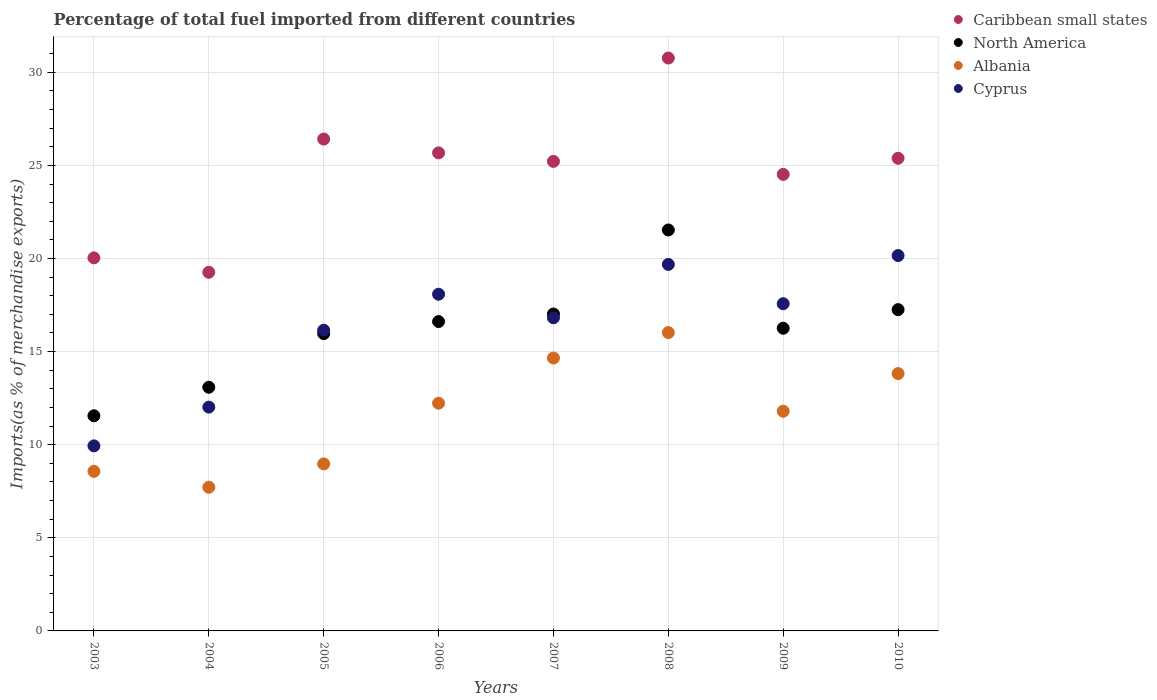Is the number of dotlines equal to the number of legend labels?
Ensure brevity in your answer.  Yes. What is the percentage of imports to different countries in Cyprus in 2005?
Provide a short and direct response. 16.15. Across all years, what is the maximum percentage of imports to different countries in Albania?
Keep it short and to the point. 16.02. Across all years, what is the minimum percentage of imports to different countries in Cyprus?
Offer a very short reply. 9.94. In which year was the percentage of imports to different countries in Cyprus minimum?
Give a very brief answer. 2003. What is the total percentage of imports to different countries in Cyprus in the graph?
Make the answer very short. 130.41. What is the difference between the percentage of imports to different countries in Caribbean small states in 2008 and that in 2009?
Provide a short and direct response. 6.25. What is the difference between the percentage of imports to different countries in Cyprus in 2007 and the percentage of imports to different countries in North America in 2009?
Your response must be concise. 0.56. What is the average percentage of imports to different countries in Albania per year?
Offer a terse response. 11.72. In the year 2003, what is the difference between the percentage of imports to different countries in Cyprus and percentage of imports to different countries in North America?
Provide a succinct answer. -1.62. In how many years, is the percentage of imports to different countries in North America greater than 29 %?
Your answer should be compact. 0. What is the ratio of the percentage of imports to different countries in North America in 2008 to that in 2010?
Your answer should be compact. 1.25. What is the difference between the highest and the second highest percentage of imports to different countries in Albania?
Your answer should be compact. 1.37. What is the difference between the highest and the lowest percentage of imports to different countries in Caribbean small states?
Your answer should be compact. 11.51. Is the sum of the percentage of imports to different countries in Cyprus in 2003 and 2004 greater than the maximum percentage of imports to different countries in North America across all years?
Your answer should be compact. Yes. Does the percentage of imports to different countries in Cyprus monotonically increase over the years?
Provide a succinct answer. No. Is the percentage of imports to different countries in North America strictly greater than the percentage of imports to different countries in Cyprus over the years?
Make the answer very short. No. Does the graph contain any zero values?
Ensure brevity in your answer.  No. Where does the legend appear in the graph?
Offer a terse response. Top right. What is the title of the graph?
Give a very brief answer. Percentage of total fuel imported from different countries. Does "Monaco" appear as one of the legend labels in the graph?
Provide a succinct answer. No. What is the label or title of the Y-axis?
Your answer should be very brief. Imports(as % of merchandise exports). What is the Imports(as % of merchandise exports) in Caribbean small states in 2003?
Your response must be concise. 20.03. What is the Imports(as % of merchandise exports) in North America in 2003?
Your response must be concise. 11.55. What is the Imports(as % of merchandise exports) in Albania in 2003?
Your response must be concise. 8.57. What is the Imports(as % of merchandise exports) in Cyprus in 2003?
Provide a succinct answer. 9.94. What is the Imports(as % of merchandise exports) of Caribbean small states in 2004?
Keep it short and to the point. 19.26. What is the Imports(as % of merchandise exports) in North America in 2004?
Give a very brief answer. 13.08. What is the Imports(as % of merchandise exports) in Albania in 2004?
Your response must be concise. 7.71. What is the Imports(as % of merchandise exports) of Cyprus in 2004?
Your answer should be very brief. 12.02. What is the Imports(as % of merchandise exports) of Caribbean small states in 2005?
Offer a terse response. 26.41. What is the Imports(as % of merchandise exports) of North America in 2005?
Your answer should be compact. 15.96. What is the Imports(as % of merchandise exports) in Albania in 2005?
Keep it short and to the point. 8.97. What is the Imports(as % of merchandise exports) in Cyprus in 2005?
Make the answer very short. 16.15. What is the Imports(as % of merchandise exports) of Caribbean small states in 2006?
Make the answer very short. 25.67. What is the Imports(as % of merchandise exports) in North America in 2006?
Make the answer very short. 16.61. What is the Imports(as % of merchandise exports) in Albania in 2006?
Your answer should be very brief. 12.23. What is the Imports(as % of merchandise exports) of Cyprus in 2006?
Your answer should be very brief. 18.08. What is the Imports(as % of merchandise exports) of Caribbean small states in 2007?
Your answer should be compact. 25.22. What is the Imports(as % of merchandise exports) of North America in 2007?
Offer a very short reply. 17.02. What is the Imports(as % of merchandise exports) of Albania in 2007?
Your answer should be very brief. 14.66. What is the Imports(as % of merchandise exports) in Cyprus in 2007?
Provide a succinct answer. 16.82. What is the Imports(as % of merchandise exports) in Caribbean small states in 2008?
Keep it short and to the point. 30.76. What is the Imports(as % of merchandise exports) in North America in 2008?
Offer a very short reply. 21.53. What is the Imports(as % of merchandise exports) of Albania in 2008?
Give a very brief answer. 16.02. What is the Imports(as % of merchandise exports) in Cyprus in 2008?
Offer a terse response. 19.68. What is the Imports(as % of merchandise exports) of Caribbean small states in 2009?
Offer a terse response. 24.52. What is the Imports(as % of merchandise exports) in North America in 2009?
Provide a succinct answer. 16.25. What is the Imports(as % of merchandise exports) in Albania in 2009?
Keep it short and to the point. 11.8. What is the Imports(as % of merchandise exports) in Cyprus in 2009?
Your answer should be compact. 17.57. What is the Imports(as % of merchandise exports) of Caribbean small states in 2010?
Ensure brevity in your answer.  25.38. What is the Imports(as % of merchandise exports) in North America in 2010?
Offer a very short reply. 17.25. What is the Imports(as % of merchandise exports) of Albania in 2010?
Offer a terse response. 13.82. What is the Imports(as % of merchandise exports) of Cyprus in 2010?
Your answer should be very brief. 20.16. Across all years, what is the maximum Imports(as % of merchandise exports) of Caribbean small states?
Make the answer very short. 30.76. Across all years, what is the maximum Imports(as % of merchandise exports) of North America?
Provide a short and direct response. 21.53. Across all years, what is the maximum Imports(as % of merchandise exports) of Albania?
Keep it short and to the point. 16.02. Across all years, what is the maximum Imports(as % of merchandise exports) in Cyprus?
Offer a terse response. 20.16. Across all years, what is the minimum Imports(as % of merchandise exports) in Caribbean small states?
Make the answer very short. 19.26. Across all years, what is the minimum Imports(as % of merchandise exports) in North America?
Provide a succinct answer. 11.55. Across all years, what is the minimum Imports(as % of merchandise exports) in Albania?
Offer a very short reply. 7.71. Across all years, what is the minimum Imports(as % of merchandise exports) of Cyprus?
Give a very brief answer. 9.94. What is the total Imports(as % of merchandise exports) of Caribbean small states in the graph?
Provide a succinct answer. 197.26. What is the total Imports(as % of merchandise exports) of North America in the graph?
Provide a short and direct response. 129.27. What is the total Imports(as % of merchandise exports) in Albania in the graph?
Provide a succinct answer. 93.78. What is the total Imports(as % of merchandise exports) of Cyprus in the graph?
Give a very brief answer. 130.41. What is the difference between the Imports(as % of merchandise exports) of Caribbean small states in 2003 and that in 2004?
Offer a terse response. 0.77. What is the difference between the Imports(as % of merchandise exports) in North America in 2003 and that in 2004?
Your answer should be very brief. -1.53. What is the difference between the Imports(as % of merchandise exports) in Albania in 2003 and that in 2004?
Keep it short and to the point. 0.86. What is the difference between the Imports(as % of merchandise exports) in Cyprus in 2003 and that in 2004?
Make the answer very short. -2.08. What is the difference between the Imports(as % of merchandise exports) of Caribbean small states in 2003 and that in 2005?
Offer a very short reply. -6.38. What is the difference between the Imports(as % of merchandise exports) of North America in 2003 and that in 2005?
Your answer should be compact. -4.41. What is the difference between the Imports(as % of merchandise exports) of Albania in 2003 and that in 2005?
Ensure brevity in your answer.  -0.4. What is the difference between the Imports(as % of merchandise exports) of Cyprus in 2003 and that in 2005?
Your answer should be very brief. -6.21. What is the difference between the Imports(as % of merchandise exports) in Caribbean small states in 2003 and that in 2006?
Your answer should be very brief. -5.64. What is the difference between the Imports(as % of merchandise exports) of North America in 2003 and that in 2006?
Ensure brevity in your answer.  -5.06. What is the difference between the Imports(as % of merchandise exports) in Albania in 2003 and that in 2006?
Offer a very short reply. -3.66. What is the difference between the Imports(as % of merchandise exports) of Cyprus in 2003 and that in 2006?
Offer a very short reply. -8.14. What is the difference between the Imports(as % of merchandise exports) in Caribbean small states in 2003 and that in 2007?
Offer a terse response. -5.18. What is the difference between the Imports(as % of merchandise exports) in North America in 2003 and that in 2007?
Offer a terse response. -5.46. What is the difference between the Imports(as % of merchandise exports) of Albania in 2003 and that in 2007?
Ensure brevity in your answer.  -6.08. What is the difference between the Imports(as % of merchandise exports) of Cyprus in 2003 and that in 2007?
Give a very brief answer. -6.88. What is the difference between the Imports(as % of merchandise exports) in Caribbean small states in 2003 and that in 2008?
Your answer should be very brief. -10.73. What is the difference between the Imports(as % of merchandise exports) of North America in 2003 and that in 2008?
Ensure brevity in your answer.  -9.98. What is the difference between the Imports(as % of merchandise exports) in Albania in 2003 and that in 2008?
Your answer should be compact. -7.45. What is the difference between the Imports(as % of merchandise exports) of Cyprus in 2003 and that in 2008?
Your answer should be compact. -9.74. What is the difference between the Imports(as % of merchandise exports) in Caribbean small states in 2003 and that in 2009?
Your response must be concise. -4.48. What is the difference between the Imports(as % of merchandise exports) of North America in 2003 and that in 2009?
Your response must be concise. -4.7. What is the difference between the Imports(as % of merchandise exports) of Albania in 2003 and that in 2009?
Ensure brevity in your answer.  -3.23. What is the difference between the Imports(as % of merchandise exports) in Cyprus in 2003 and that in 2009?
Make the answer very short. -7.63. What is the difference between the Imports(as % of merchandise exports) of Caribbean small states in 2003 and that in 2010?
Provide a succinct answer. -5.35. What is the difference between the Imports(as % of merchandise exports) in North America in 2003 and that in 2010?
Give a very brief answer. -5.7. What is the difference between the Imports(as % of merchandise exports) of Albania in 2003 and that in 2010?
Your answer should be very brief. -5.25. What is the difference between the Imports(as % of merchandise exports) in Cyprus in 2003 and that in 2010?
Keep it short and to the point. -10.22. What is the difference between the Imports(as % of merchandise exports) in Caribbean small states in 2004 and that in 2005?
Offer a very short reply. -7.16. What is the difference between the Imports(as % of merchandise exports) of North America in 2004 and that in 2005?
Your answer should be very brief. -2.88. What is the difference between the Imports(as % of merchandise exports) of Albania in 2004 and that in 2005?
Keep it short and to the point. -1.25. What is the difference between the Imports(as % of merchandise exports) in Cyprus in 2004 and that in 2005?
Keep it short and to the point. -4.13. What is the difference between the Imports(as % of merchandise exports) in Caribbean small states in 2004 and that in 2006?
Make the answer very short. -6.41. What is the difference between the Imports(as % of merchandise exports) in North America in 2004 and that in 2006?
Ensure brevity in your answer.  -3.53. What is the difference between the Imports(as % of merchandise exports) in Albania in 2004 and that in 2006?
Keep it short and to the point. -4.51. What is the difference between the Imports(as % of merchandise exports) in Cyprus in 2004 and that in 2006?
Your response must be concise. -6.06. What is the difference between the Imports(as % of merchandise exports) of Caribbean small states in 2004 and that in 2007?
Give a very brief answer. -5.96. What is the difference between the Imports(as % of merchandise exports) in North America in 2004 and that in 2007?
Offer a terse response. -3.93. What is the difference between the Imports(as % of merchandise exports) of Albania in 2004 and that in 2007?
Make the answer very short. -6.94. What is the difference between the Imports(as % of merchandise exports) in Cyprus in 2004 and that in 2007?
Provide a short and direct response. -4.8. What is the difference between the Imports(as % of merchandise exports) of Caribbean small states in 2004 and that in 2008?
Keep it short and to the point. -11.51. What is the difference between the Imports(as % of merchandise exports) of North America in 2004 and that in 2008?
Make the answer very short. -8.45. What is the difference between the Imports(as % of merchandise exports) of Albania in 2004 and that in 2008?
Offer a terse response. -8.31. What is the difference between the Imports(as % of merchandise exports) in Cyprus in 2004 and that in 2008?
Make the answer very short. -7.66. What is the difference between the Imports(as % of merchandise exports) in Caribbean small states in 2004 and that in 2009?
Give a very brief answer. -5.26. What is the difference between the Imports(as % of merchandise exports) of North America in 2004 and that in 2009?
Provide a succinct answer. -3.17. What is the difference between the Imports(as % of merchandise exports) of Albania in 2004 and that in 2009?
Your answer should be compact. -4.08. What is the difference between the Imports(as % of merchandise exports) of Cyprus in 2004 and that in 2009?
Give a very brief answer. -5.55. What is the difference between the Imports(as % of merchandise exports) in Caribbean small states in 2004 and that in 2010?
Provide a short and direct response. -6.12. What is the difference between the Imports(as % of merchandise exports) in North America in 2004 and that in 2010?
Give a very brief answer. -4.17. What is the difference between the Imports(as % of merchandise exports) in Albania in 2004 and that in 2010?
Offer a very short reply. -6.1. What is the difference between the Imports(as % of merchandise exports) of Cyprus in 2004 and that in 2010?
Provide a succinct answer. -8.14. What is the difference between the Imports(as % of merchandise exports) in Caribbean small states in 2005 and that in 2006?
Provide a short and direct response. 0.74. What is the difference between the Imports(as % of merchandise exports) in North America in 2005 and that in 2006?
Your answer should be compact. -0.65. What is the difference between the Imports(as % of merchandise exports) in Albania in 2005 and that in 2006?
Make the answer very short. -3.26. What is the difference between the Imports(as % of merchandise exports) in Cyprus in 2005 and that in 2006?
Your answer should be compact. -1.93. What is the difference between the Imports(as % of merchandise exports) of Caribbean small states in 2005 and that in 2007?
Your response must be concise. 1.2. What is the difference between the Imports(as % of merchandise exports) in North America in 2005 and that in 2007?
Your answer should be compact. -1.05. What is the difference between the Imports(as % of merchandise exports) of Albania in 2005 and that in 2007?
Your response must be concise. -5.69. What is the difference between the Imports(as % of merchandise exports) of Cyprus in 2005 and that in 2007?
Ensure brevity in your answer.  -0.67. What is the difference between the Imports(as % of merchandise exports) of Caribbean small states in 2005 and that in 2008?
Give a very brief answer. -4.35. What is the difference between the Imports(as % of merchandise exports) of North America in 2005 and that in 2008?
Provide a short and direct response. -5.57. What is the difference between the Imports(as % of merchandise exports) of Albania in 2005 and that in 2008?
Your response must be concise. -7.05. What is the difference between the Imports(as % of merchandise exports) of Cyprus in 2005 and that in 2008?
Give a very brief answer. -3.53. What is the difference between the Imports(as % of merchandise exports) of Caribbean small states in 2005 and that in 2009?
Provide a short and direct response. 1.9. What is the difference between the Imports(as % of merchandise exports) in North America in 2005 and that in 2009?
Provide a short and direct response. -0.29. What is the difference between the Imports(as % of merchandise exports) in Albania in 2005 and that in 2009?
Provide a short and direct response. -2.83. What is the difference between the Imports(as % of merchandise exports) of Cyprus in 2005 and that in 2009?
Keep it short and to the point. -1.42. What is the difference between the Imports(as % of merchandise exports) of Caribbean small states in 2005 and that in 2010?
Offer a very short reply. 1.03. What is the difference between the Imports(as % of merchandise exports) in North America in 2005 and that in 2010?
Offer a terse response. -1.29. What is the difference between the Imports(as % of merchandise exports) in Albania in 2005 and that in 2010?
Ensure brevity in your answer.  -4.85. What is the difference between the Imports(as % of merchandise exports) in Cyprus in 2005 and that in 2010?
Provide a succinct answer. -4.01. What is the difference between the Imports(as % of merchandise exports) in Caribbean small states in 2006 and that in 2007?
Make the answer very short. 0.46. What is the difference between the Imports(as % of merchandise exports) of North America in 2006 and that in 2007?
Provide a succinct answer. -0.41. What is the difference between the Imports(as % of merchandise exports) of Albania in 2006 and that in 2007?
Offer a terse response. -2.43. What is the difference between the Imports(as % of merchandise exports) of Cyprus in 2006 and that in 2007?
Ensure brevity in your answer.  1.26. What is the difference between the Imports(as % of merchandise exports) of Caribbean small states in 2006 and that in 2008?
Your response must be concise. -5.09. What is the difference between the Imports(as % of merchandise exports) in North America in 2006 and that in 2008?
Your response must be concise. -4.92. What is the difference between the Imports(as % of merchandise exports) of Albania in 2006 and that in 2008?
Keep it short and to the point. -3.79. What is the difference between the Imports(as % of merchandise exports) of Cyprus in 2006 and that in 2008?
Ensure brevity in your answer.  -1.6. What is the difference between the Imports(as % of merchandise exports) of Caribbean small states in 2006 and that in 2009?
Provide a short and direct response. 1.16. What is the difference between the Imports(as % of merchandise exports) of North America in 2006 and that in 2009?
Give a very brief answer. 0.36. What is the difference between the Imports(as % of merchandise exports) of Albania in 2006 and that in 2009?
Provide a short and direct response. 0.43. What is the difference between the Imports(as % of merchandise exports) of Cyprus in 2006 and that in 2009?
Your answer should be very brief. 0.51. What is the difference between the Imports(as % of merchandise exports) in Caribbean small states in 2006 and that in 2010?
Keep it short and to the point. 0.29. What is the difference between the Imports(as % of merchandise exports) of North America in 2006 and that in 2010?
Your answer should be very brief. -0.64. What is the difference between the Imports(as % of merchandise exports) in Albania in 2006 and that in 2010?
Provide a succinct answer. -1.59. What is the difference between the Imports(as % of merchandise exports) in Cyprus in 2006 and that in 2010?
Your answer should be compact. -2.08. What is the difference between the Imports(as % of merchandise exports) of Caribbean small states in 2007 and that in 2008?
Give a very brief answer. -5.55. What is the difference between the Imports(as % of merchandise exports) in North America in 2007 and that in 2008?
Give a very brief answer. -4.51. What is the difference between the Imports(as % of merchandise exports) of Albania in 2007 and that in 2008?
Your response must be concise. -1.37. What is the difference between the Imports(as % of merchandise exports) in Cyprus in 2007 and that in 2008?
Offer a very short reply. -2.87. What is the difference between the Imports(as % of merchandise exports) of Caribbean small states in 2007 and that in 2009?
Provide a short and direct response. 0.7. What is the difference between the Imports(as % of merchandise exports) of North America in 2007 and that in 2009?
Give a very brief answer. 0.76. What is the difference between the Imports(as % of merchandise exports) of Albania in 2007 and that in 2009?
Ensure brevity in your answer.  2.86. What is the difference between the Imports(as % of merchandise exports) in Cyprus in 2007 and that in 2009?
Keep it short and to the point. -0.76. What is the difference between the Imports(as % of merchandise exports) in Caribbean small states in 2007 and that in 2010?
Provide a short and direct response. -0.17. What is the difference between the Imports(as % of merchandise exports) of North America in 2007 and that in 2010?
Keep it short and to the point. -0.23. What is the difference between the Imports(as % of merchandise exports) in Albania in 2007 and that in 2010?
Offer a very short reply. 0.84. What is the difference between the Imports(as % of merchandise exports) of Cyprus in 2007 and that in 2010?
Keep it short and to the point. -3.34. What is the difference between the Imports(as % of merchandise exports) in Caribbean small states in 2008 and that in 2009?
Keep it short and to the point. 6.25. What is the difference between the Imports(as % of merchandise exports) in North America in 2008 and that in 2009?
Offer a very short reply. 5.28. What is the difference between the Imports(as % of merchandise exports) of Albania in 2008 and that in 2009?
Make the answer very short. 4.22. What is the difference between the Imports(as % of merchandise exports) in Cyprus in 2008 and that in 2009?
Give a very brief answer. 2.11. What is the difference between the Imports(as % of merchandise exports) of Caribbean small states in 2008 and that in 2010?
Offer a very short reply. 5.38. What is the difference between the Imports(as % of merchandise exports) in North America in 2008 and that in 2010?
Ensure brevity in your answer.  4.28. What is the difference between the Imports(as % of merchandise exports) of Albania in 2008 and that in 2010?
Offer a terse response. 2.2. What is the difference between the Imports(as % of merchandise exports) in Cyprus in 2008 and that in 2010?
Keep it short and to the point. -0.48. What is the difference between the Imports(as % of merchandise exports) of Caribbean small states in 2009 and that in 2010?
Your answer should be compact. -0.87. What is the difference between the Imports(as % of merchandise exports) of North America in 2009 and that in 2010?
Offer a very short reply. -1. What is the difference between the Imports(as % of merchandise exports) in Albania in 2009 and that in 2010?
Offer a very short reply. -2.02. What is the difference between the Imports(as % of merchandise exports) of Cyprus in 2009 and that in 2010?
Offer a terse response. -2.59. What is the difference between the Imports(as % of merchandise exports) in Caribbean small states in 2003 and the Imports(as % of merchandise exports) in North America in 2004?
Offer a terse response. 6.95. What is the difference between the Imports(as % of merchandise exports) in Caribbean small states in 2003 and the Imports(as % of merchandise exports) in Albania in 2004?
Your answer should be very brief. 12.32. What is the difference between the Imports(as % of merchandise exports) in Caribbean small states in 2003 and the Imports(as % of merchandise exports) in Cyprus in 2004?
Your response must be concise. 8.02. What is the difference between the Imports(as % of merchandise exports) in North America in 2003 and the Imports(as % of merchandise exports) in Albania in 2004?
Ensure brevity in your answer.  3.84. What is the difference between the Imports(as % of merchandise exports) of North America in 2003 and the Imports(as % of merchandise exports) of Cyprus in 2004?
Ensure brevity in your answer.  -0.46. What is the difference between the Imports(as % of merchandise exports) of Albania in 2003 and the Imports(as % of merchandise exports) of Cyprus in 2004?
Offer a terse response. -3.45. What is the difference between the Imports(as % of merchandise exports) of Caribbean small states in 2003 and the Imports(as % of merchandise exports) of North America in 2005?
Ensure brevity in your answer.  4.07. What is the difference between the Imports(as % of merchandise exports) of Caribbean small states in 2003 and the Imports(as % of merchandise exports) of Albania in 2005?
Keep it short and to the point. 11.06. What is the difference between the Imports(as % of merchandise exports) in Caribbean small states in 2003 and the Imports(as % of merchandise exports) in Cyprus in 2005?
Your answer should be compact. 3.88. What is the difference between the Imports(as % of merchandise exports) of North America in 2003 and the Imports(as % of merchandise exports) of Albania in 2005?
Ensure brevity in your answer.  2.58. What is the difference between the Imports(as % of merchandise exports) in North America in 2003 and the Imports(as % of merchandise exports) in Cyprus in 2005?
Your response must be concise. -4.6. What is the difference between the Imports(as % of merchandise exports) in Albania in 2003 and the Imports(as % of merchandise exports) in Cyprus in 2005?
Offer a very short reply. -7.58. What is the difference between the Imports(as % of merchandise exports) of Caribbean small states in 2003 and the Imports(as % of merchandise exports) of North America in 2006?
Your response must be concise. 3.42. What is the difference between the Imports(as % of merchandise exports) of Caribbean small states in 2003 and the Imports(as % of merchandise exports) of Albania in 2006?
Provide a short and direct response. 7.8. What is the difference between the Imports(as % of merchandise exports) of Caribbean small states in 2003 and the Imports(as % of merchandise exports) of Cyprus in 2006?
Offer a very short reply. 1.95. What is the difference between the Imports(as % of merchandise exports) in North America in 2003 and the Imports(as % of merchandise exports) in Albania in 2006?
Give a very brief answer. -0.67. What is the difference between the Imports(as % of merchandise exports) in North America in 2003 and the Imports(as % of merchandise exports) in Cyprus in 2006?
Provide a succinct answer. -6.53. What is the difference between the Imports(as % of merchandise exports) of Albania in 2003 and the Imports(as % of merchandise exports) of Cyprus in 2006?
Offer a very short reply. -9.51. What is the difference between the Imports(as % of merchandise exports) in Caribbean small states in 2003 and the Imports(as % of merchandise exports) in North America in 2007?
Provide a succinct answer. 3.02. What is the difference between the Imports(as % of merchandise exports) in Caribbean small states in 2003 and the Imports(as % of merchandise exports) in Albania in 2007?
Make the answer very short. 5.38. What is the difference between the Imports(as % of merchandise exports) of Caribbean small states in 2003 and the Imports(as % of merchandise exports) of Cyprus in 2007?
Your response must be concise. 3.22. What is the difference between the Imports(as % of merchandise exports) of North America in 2003 and the Imports(as % of merchandise exports) of Albania in 2007?
Your answer should be compact. -3.1. What is the difference between the Imports(as % of merchandise exports) of North America in 2003 and the Imports(as % of merchandise exports) of Cyprus in 2007?
Your answer should be compact. -5.26. What is the difference between the Imports(as % of merchandise exports) of Albania in 2003 and the Imports(as % of merchandise exports) of Cyprus in 2007?
Ensure brevity in your answer.  -8.25. What is the difference between the Imports(as % of merchandise exports) of Caribbean small states in 2003 and the Imports(as % of merchandise exports) of North America in 2008?
Your answer should be very brief. -1.5. What is the difference between the Imports(as % of merchandise exports) in Caribbean small states in 2003 and the Imports(as % of merchandise exports) in Albania in 2008?
Give a very brief answer. 4.01. What is the difference between the Imports(as % of merchandise exports) of Caribbean small states in 2003 and the Imports(as % of merchandise exports) of Cyprus in 2008?
Ensure brevity in your answer.  0.35. What is the difference between the Imports(as % of merchandise exports) in North America in 2003 and the Imports(as % of merchandise exports) in Albania in 2008?
Keep it short and to the point. -4.47. What is the difference between the Imports(as % of merchandise exports) of North America in 2003 and the Imports(as % of merchandise exports) of Cyprus in 2008?
Offer a very short reply. -8.13. What is the difference between the Imports(as % of merchandise exports) of Albania in 2003 and the Imports(as % of merchandise exports) of Cyprus in 2008?
Offer a very short reply. -11.11. What is the difference between the Imports(as % of merchandise exports) in Caribbean small states in 2003 and the Imports(as % of merchandise exports) in North America in 2009?
Offer a terse response. 3.78. What is the difference between the Imports(as % of merchandise exports) of Caribbean small states in 2003 and the Imports(as % of merchandise exports) of Albania in 2009?
Offer a very short reply. 8.24. What is the difference between the Imports(as % of merchandise exports) in Caribbean small states in 2003 and the Imports(as % of merchandise exports) in Cyprus in 2009?
Make the answer very short. 2.46. What is the difference between the Imports(as % of merchandise exports) of North America in 2003 and the Imports(as % of merchandise exports) of Albania in 2009?
Offer a terse response. -0.24. What is the difference between the Imports(as % of merchandise exports) of North America in 2003 and the Imports(as % of merchandise exports) of Cyprus in 2009?
Offer a terse response. -6.02. What is the difference between the Imports(as % of merchandise exports) of Albania in 2003 and the Imports(as % of merchandise exports) of Cyprus in 2009?
Your answer should be very brief. -9. What is the difference between the Imports(as % of merchandise exports) of Caribbean small states in 2003 and the Imports(as % of merchandise exports) of North America in 2010?
Offer a terse response. 2.78. What is the difference between the Imports(as % of merchandise exports) in Caribbean small states in 2003 and the Imports(as % of merchandise exports) in Albania in 2010?
Offer a terse response. 6.22. What is the difference between the Imports(as % of merchandise exports) of Caribbean small states in 2003 and the Imports(as % of merchandise exports) of Cyprus in 2010?
Provide a succinct answer. -0.12. What is the difference between the Imports(as % of merchandise exports) of North America in 2003 and the Imports(as % of merchandise exports) of Albania in 2010?
Give a very brief answer. -2.26. What is the difference between the Imports(as % of merchandise exports) in North America in 2003 and the Imports(as % of merchandise exports) in Cyprus in 2010?
Offer a very short reply. -8.6. What is the difference between the Imports(as % of merchandise exports) of Albania in 2003 and the Imports(as % of merchandise exports) of Cyprus in 2010?
Provide a short and direct response. -11.59. What is the difference between the Imports(as % of merchandise exports) of Caribbean small states in 2004 and the Imports(as % of merchandise exports) of North America in 2005?
Offer a terse response. 3.29. What is the difference between the Imports(as % of merchandise exports) in Caribbean small states in 2004 and the Imports(as % of merchandise exports) in Albania in 2005?
Provide a succinct answer. 10.29. What is the difference between the Imports(as % of merchandise exports) of Caribbean small states in 2004 and the Imports(as % of merchandise exports) of Cyprus in 2005?
Offer a very short reply. 3.11. What is the difference between the Imports(as % of merchandise exports) of North America in 2004 and the Imports(as % of merchandise exports) of Albania in 2005?
Offer a very short reply. 4.12. What is the difference between the Imports(as % of merchandise exports) of North America in 2004 and the Imports(as % of merchandise exports) of Cyprus in 2005?
Your answer should be compact. -3.06. What is the difference between the Imports(as % of merchandise exports) of Albania in 2004 and the Imports(as % of merchandise exports) of Cyprus in 2005?
Give a very brief answer. -8.43. What is the difference between the Imports(as % of merchandise exports) of Caribbean small states in 2004 and the Imports(as % of merchandise exports) of North America in 2006?
Give a very brief answer. 2.65. What is the difference between the Imports(as % of merchandise exports) of Caribbean small states in 2004 and the Imports(as % of merchandise exports) of Albania in 2006?
Your answer should be compact. 7.03. What is the difference between the Imports(as % of merchandise exports) in Caribbean small states in 2004 and the Imports(as % of merchandise exports) in Cyprus in 2006?
Offer a terse response. 1.18. What is the difference between the Imports(as % of merchandise exports) of North America in 2004 and the Imports(as % of merchandise exports) of Albania in 2006?
Your answer should be very brief. 0.86. What is the difference between the Imports(as % of merchandise exports) in North America in 2004 and the Imports(as % of merchandise exports) in Cyprus in 2006?
Your answer should be compact. -5. What is the difference between the Imports(as % of merchandise exports) of Albania in 2004 and the Imports(as % of merchandise exports) of Cyprus in 2006?
Your response must be concise. -10.37. What is the difference between the Imports(as % of merchandise exports) in Caribbean small states in 2004 and the Imports(as % of merchandise exports) in North America in 2007?
Keep it short and to the point. 2.24. What is the difference between the Imports(as % of merchandise exports) in Caribbean small states in 2004 and the Imports(as % of merchandise exports) in Albania in 2007?
Your response must be concise. 4.6. What is the difference between the Imports(as % of merchandise exports) of Caribbean small states in 2004 and the Imports(as % of merchandise exports) of Cyprus in 2007?
Provide a short and direct response. 2.44. What is the difference between the Imports(as % of merchandise exports) in North America in 2004 and the Imports(as % of merchandise exports) in Albania in 2007?
Your answer should be compact. -1.57. What is the difference between the Imports(as % of merchandise exports) of North America in 2004 and the Imports(as % of merchandise exports) of Cyprus in 2007?
Make the answer very short. -3.73. What is the difference between the Imports(as % of merchandise exports) of Albania in 2004 and the Imports(as % of merchandise exports) of Cyprus in 2007?
Make the answer very short. -9.1. What is the difference between the Imports(as % of merchandise exports) of Caribbean small states in 2004 and the Imports(as % of merchandise exports) of North America in 2008?
Give a very brief answer. -2.27. What is the difference between the Imports(as % of merchandise exports) of Caribbean small states in 2004 and the Imports(as % of merchandise exports) of Albania in 2008?
Your answer should be very brief. 3.24. What is the difference between the Imports(as % of merchandise exports) in Caribbean small states in 2004 and the Imports(as % of merchandise exports) in Cyprus in 2008?
Offer a terse response. -0.42. What is the difference between the Imports(as % of merchandise exports) of North America in 2004 and the Imports(as % of merchandise exports) of Albania in 2008?
Keep it short and to the point. -2.94. What is the difference between the Imports(as % of merchandise exports) in North America in 2004 and the Imports(as % of merchandise exports) in Cyprus in 2008?
Your response must be concise. -6.6. What is the difference between the Imports(as % of merchandise exports) in Albania in 2004 and the Imports(as % of merchandise exports) in Cyprus in 2008?
Ensure brevity in your answer.  -11.97. What is the difference between the Imports(as % of merchandise exports) in Caribbean small states in 2004 and the Imports(as % of merchandise exports) in North America in 2009?
Your response must be concise. 3. What is the difference between the Imports(as % of merchandise exports) in Caribbean small states in 2004 and the Imports(as % of merchandise exports) in Albania in 2009?
Keep it short and to the point. 7.46. What is the difference between the Imports(as % of merchandise exports) of Caribbean small states in 2004 and the Imports(as % of merchandise exports) of Cyprus in 2009?
Provide a succinct answer. 1.69. What is the difference between the Imports(as % of merchandise exports) in North America in 2004 and the Imports(as % of merchandise exports) in Albania in 2009?
Provide a short and direct response. 1.29. What is the difference between the Imports(as % of merchandise exports) of North America in 2004 and the Imports(as % of merchandise exports) of Cyprus in 2009?
Ensure brevity in your answer.  -4.49. What is the difference between the Imports(as % of merchandise exports) of Albania in 2004 and the Imports(as % of merchandise exports) of Cyprus in 2009?
Make the answer very short. -9.86. What is the difference between the Imports(as % of merchandise exports) in Caribbean small states in 2004 and the Imports(as % of merchandise exports) in North America in 2010?
Provide a short and direct response. 2.01. What is the difference between the Imports(as % of merchandise exports) of Caribbean small states in 2004 and the Imports(as % of merchandise exports) of Albania in 2010?
Provide a succinct answer. 5.44. What is the difference between the Imports(as % of merchandise exports) of Caribbean small states in 2004 and the Imports(as % of merchandise exports) of Cyprus in 2010?
Your answer should be very brief. -0.9. What is the difference between the Imports(as % of merchandise exports) of North America in 2004 and the Imports(as % of merchandise exports) of Albania in 2010?
Your answer should be very brief. -0.73. What is the difference between the Imports(as % of merchandise exports) in North America in 2004 and the Imports(as % of merchandise exports) in Cyprus in 2010?
Your answer should be compact. -7.07. What is the difference between the Imports(as % of merchandise exports) in Albania in 2004 and the Imports(as % of merchandise exports) in Cyprus in 2010?
Provide a short and direct response. -12.44. What is the difference between the Imports(as % of merchandise exports) of Caribbean small states in 2005 and the Imports(as % of merchandise exports) of North America in 2006?
Offer a very short reply. 9.8. What is the difference between the Imports(as % of merchandise exports) of Caribbean small states in 2005 and the Imports(as % of merchandise exports) of Albania in 2006?
Offer a very short reply. 14.19. What is the difference between the Imports(as % of merchandise exports) in Caribbean small states in 2005 and the Imports(as % of merchandise exports) in Cyprus in 2006?
Keep it short and to the point. 8.33. What is the difference between the Imports(as % of merchandise exports) in North America in 2005 and the Imports(as % of merchandise exports) in Albania in 2006?
Provide a short and direct response. 3.74. What is the difference between the Imports(as % of merchandise exports) of North America in 2005 and the Imports(as % of merchandise exports) of Cyprus in 2006?
Your answer should be compact. -2.12. What is the difference between the Imports(as % of merchandise exports) of Albania in 2005 and the Imports(as % of merchandise exports) of Cyprus in 2006?
Offer a very short reply. -9.11. What is the difference between the Imports(as % of merchandise exports) in Caribbean small states in 2005 and the Imports(as % of merchandise exports) in North America in 2007?
Your response must be concise. 9.4. What is the difference between the Imports(as % of merchandise exports) in Caribbean small states in 2005 and the Imports(as % of merchandise exports) in Albania in 2007?
Ensure brevity in your answer.  11.76. What is the difference between the Imports(as % of merchandise exports) of Caribbean small states in 2005 and the Imports(as % of merchandise exports) of Cyprus in 2007?
Provide a succinct answer. 9.6. What is the difference between the Imports(as % of merchandise exports) in North America in 2005 and the Imports(as % of merchandise exports) in Albania in 2007?
Ensure brevity in your answer.  1.31. What is the difference between the Imports(as % of merchandise exports) in North America in 2005 and the Imports(as % of merchandise exports) in Cyprus in 2007?
Offer a very short reply. -0.85. What is the difference between the Imports(as % of merchandise exports) in Albania in 2005 and the Imports(as % of merchandise exports) in Cyprus in 2007?
Your answer should be compact. -7.85. What is the difference between the Imports(as % of merchandise exports) in Caribbean small states in 2005 and the Imports(as % of merchandise exports) in North America in 2008?
Your answer should be very brief. 4.88. What is the difference between the Imports(as % of merchandise exports) of Caribbean small states in 2005 and the Imports(as % of merchandise exports) of Albania in 2008?
Provide a short and direct response. 10.39. What is the difference between the Imports(as % of merchandise exports) of Caribbean small states in 2005 and the Imports(as % of merchandise exports) of Cyprus in 2008?
Your response must be concise. 6.73. What is the difference between the Imports(as % of merchandise exports) in North America in 2005 and the Imports(as % of merchandise exports) in Albania in 2008?
Your answer should be very brief. -0.06. What is the difference between the Imports(as % of merchandise exports) in North America in 2005 and the Imports(as % of merchandise exports) in Cyprus in 2008?
Provide a succinct answer. -3.72. What is the difference between the Imports(as % of merchandise exports) in Albania in 2005 and the Imports(as % of merchandise exports) in Cyprus in 2008?
Offer a terse response. -10.71. What is the difference between the Imports(as % of merchandise exports) of Caribbean small states in 2005 and the Imports(as % of merchandise exports) of North America in 2009?
Offer a terse response. 10.16. What is the difference between the Imports(as % of merchandise exports) of Caribbean small states in 2005 and the Imports(as % of merchandise exports) of Albania in 2009?
Ensure brevity in your answer.  14.62. What is the difference between the Imports(as % of merchandise exports) of Caribbean small states in 2005 and the Imports(as % of merchandise exports) of Cyprus in 2009?
Offer a terse response. 8.84. What is the difference between the Imports(as % of merchandise exports) in North America in 2005 and the Imports(as % of merchandise exports) in Albania in 2009?
Keep it short and to the point. 4.17. What is the difference between the Imports(as % of merchandise exports) in North America in 2005 and the Imports(as % of merchandise exports) in Cyprus in 2009?
Provide a succinct answer. -1.61. What is the difference between the Imports(as % of merchandise exports) in Albania in 2005 and the Imports(as % of merchandise exports) in Cyprus in 2009?
Offer a very short reply. -8.6. What is the difference between the Imports(as % of merchandise exports) in Caribbean small states in 2005 and the Imports(as % of merchandise exports) in North America in 2010?
Your response must be concise. 9.16. What is the difference between the Imports(as % of merchandise exports) of Caribbean small states in 2005 and the Imports(as % of merchandise exports) of Albania in 2010?
Your response must be concise. 12.6. What is the difference between the Imports(as % of merchandise exports) of Caribbean small states in 2005 and the Imports(as % of merchandise exports) of Cyprus in 2010?
Keep it short and to the point. 6.26. What is the difference between the Imports(as % of merchandise exports) in North America in 2005 and the Imports(as % of merchandise exports) in Albania in 2010?
Offer a terse response. 2.15. What is the difference between the Imports(as % of merchandise exports) in North America in 2005 and the Imports(as % of merchandise exports) in Cyprus in 2010?
Provide a succinct answer. -4.19. What is the difference between the Imports(as % of merchandise exports) in Albania in 2005 and the Imports(as % of merchandise exports) in Cyprus in 2010?
Make the answer very short. -11.19. What is the difference between the Imports(as % of merchandise exports) of Caribbean small states in 2006 and the Imports(as % of merchandise exports) of North America in 2007?
Provide a short and direct response. 8.65. What is the difference between the Imports(as % of merchandise exports) of Caribbean small states in 2006 and the Imports(as % of merchandise exports) of Albania in 2007?
Provide a short and direct response. 11.02. What is the difference between the Imports(as % of merchandise exports) in Caribbean small states in 2006 and the Imports(as % of merchandise exports) in Cyprus in 2007?
Provide a succinct answer. 8.86. What is the difference between the Imports(as % of merchandise exports) in North America in 2006 and the Imports(as % of merchandise exports) in Albania in 2007?
Provide a succinct answer. 1.96. What is the difference between the Imports(as % of merchandise exports) of North America in 2006 and the Imports(as % of merchandise exports) of Cyprus in 2007?
Provide a succinct answer. -0.2. What is the difference between the Imports(as % of merchandise exports) of Albania in 2006 and the Imports(as % of merchandise exports) of Cyprus in 2007?
Ensure brevity in your answer.  -4.59. What is the difference between the Imports(as % of merchandise exports) in Caribbean small states in 2006 and the Imports(as % of merchandise exports) in North America in 2008?
Provide a short and direct response. 4.14. What is the difference between the Imports(as % of merchandise exports) in Caribbean small states in 2006 and the Imports(as % of merchandise exports) in Albania in 2008?
Give a very brief answer. 9.65. What is the difference between the Imports(as % of merchandise exports) of Caribbean small states in 2006 and the Imports(as % of merchandise exports) of Cyprus in 2008?
Offer a very short reply. 5.99. What is the difference between the Imports(as % of merchandise exports) of North America in 2006 and the Imports(as % of merchandise exports) of Albania in 2008?
Ensure brevity in your answer.  0.59. What is the difference between the Imports(as % of merchandise exports) in North America in 2006 and the Imports(as % of merchandise exports) in Cyprus in 2008?
Make the answer very short. -3.07. What is the difference between the Imports(as % of merchandise exports) in Albania in 2006 and the Imports(as % of merchandise exports) in Cyprus in 2008?
Your response must be concise. -7.45. What is the difference between the Imports(as % of merchandise exports) of Caribbean small states in 2006 and the Imports(as % of merchandise exports) of North America in 2009?
Ensure brevity in your answer.  9.42. What is the difference between the Imports(as % of merchandise exports) in Caribbean small states in 2006 and the Imports(as % of merchandise exports) in Albania in 2009?
Your response must be concise. 13.87. What is the difference between the Imports(as % of merchandise exports) in Caribbean small states in 2006 and the Imports(as % of merchandise exports) in Cyprus in 2009?
Your answer should be compact. 8.1. What is the difference between the Imports(as % of merchandise exports) of North America in 2006 and the Imports(as % of merchandise exports) of Albania in 2009?
Provide a short and direct response. 4.82. What is the difference between the Imports(as % of merchandise exports) of North America in 2006 and the Imports(as % of merchandise exports) of Cyprus in 2009?
Provide a succinct answer. -0.96. What is the difference between the Imports(as % of merchandise exports) in Albania in 2006 and the Imports(as % of merchandise exports) in Cyprus in 2009?
Ensure brevity in your answer.  -5.34. What is the difference between the Imports(as % of merchandise exports) of Caribbean small states in 2006 and the Imports(as % of merchandise exports) of North America in 2010?
Offer a very short reply. 8.42. What is the difference between the Imports(as % of merchandise exports) of Caribbean small states in 2006 and the Imports(as % of merchandise exports) of Albania in 2010?
Keep it short and to the point. 11.85. What is the difference between the Imports(as % of merchandise exports) in Caribbean small states in 2006 and the Imports(as % of merchandise exports) in Cyprus in 2010?
Keep it short and to the point. 5.51. What is the difference between the Imports(as % of merchandise exports) in North America in 2006 and the Imports(as % of merchandise exports) in Albania in 2010?
Your response must be concise. 2.79. What is the difference between the Imports(as % of merchandise exports) of North America in 2006 and the Imports(as % of merchandise exports) of Cyprus in 2010?
Offer a terse response. -3.54. What is the difference between the Imports(as % of merchandise exports) in Albania in 2006 and the Imports(as % of merchandise exports) in Cyprus in 2010?
Give a very brief answer. -7.93. What is the difference between the Imports(as % of merchandise exports) of Caribbean small states in 2007 and the Imports(as % of merchandise exports) of North America in 2008?
Keep it short and to the point. 3.68. What is the difference between the Imports(as % of merchandise exports) of Caribbean small states in 2007 and the Imports(as % of merchandise exports) of Albania in 2008?
Make the answer very short. 9.19. What is the difference between the Imports(as % of merchandise exports) in Caribbean small states in 2007 and the Imports(as % of merchandise exports) in Cyprus in 2008?
Provide a short and direct response. 5.53. What is the difference between the Imports(as % of merchandise exports) in North America in 2007 and the Imports(as % of merchandise exports) in Cyprus in 2008?
Provide a short and direct response. -2.66. What is the difference between the Imports(as % of merchandise exports) in Albania in 2007 and the Imports(as % of merchandise exports) in Cyprus in 2008?
Your answer should be very brief. -5.03. What is the difference between the Imports(as % of merchandise exports) in Caribbean small states in 2007 and the Imports(as % of merchandise exports) in North America in 2009?
Provide a succinct answer. 8.96. What is the difference between the Imports(as % of merchandise exports) in Caribbean small states in 2007 and the Imports(as % of merchandise exports) in Albania in 2009?
Provide a short and direct response. 13.42. What is the difference between the Imports(as % of merchandise exports) in Caribbean small states in 2007 and the Imports(as % of merchandise exports) in Cyprus in 2009?
Give a very brief answer. 7.64. What is the difference between the Imports(as % of merchandise exports) in North America in 2007 and the Imports(as % of merchandise exports) in Albania in 2009?
Provide a succinct answer. 5.22. What is the difference between the Imports(as % of merchandise exports) in North America in 2007 and the Imports(as % of merchandise exports) in Cyprus in 2009?
Ensure brevity in your answer.  -0.55. What is the difference between the Imports(as % of merchandise exports) of Albania in 2007 and the Imports(as % of merchandise exports) of Cyprus in 2009?
Your answer should be compact. -2.92. What is the difference between the Imports(as % of merchandise exports) of Caribbean small states in 2007 and the Imports(as % of merchandise exports) of North America in 2010?
Your answer should be compact. 7.96. What is the difference between the Imports(as % of merchandise exports) in Caribbean small states in 2007 and the Imports(as % of merchandise exports) in Albania in 2010?
Give a very brief answer. 11.4. What is the difference between the Imports(as % of merchandise exports) of Caribbean small states in 2007 and the Imports(as % of merchandise exports) of Cyprus in 2010?
Your response must be concise. 5.06. What is the difference between the Imports(as % of merchandise exports) of North America in 2007 and the Imports(as % of merchandise exports) of Cyprus in 2010?
Make the answer very short. -3.14. What is the difference between the Imports(as % of merchandise exports) of Albania in 2007 and the Imports(as % of merchandise exports) of Cyprus in 2010?
Ensure brevity in your answer.  -5.5. What is the difference between the Imports(as % of merchandise exports) in Caribbean small states in 2008 and the Imports(as % of merchandise exports) in North America in 2009?
Make the answer very short. 14.51. What is the difference between the Imports(as % of merchandise exports) of Caribbean small states in 2008 and the Imports(as % of merchandise exports) of Albania in 2009?
Provide a short and direct response. 18.97. What is the difference between the Imports(as % of merchandise exports) of Caribbean small states in 2008 and the Imports(as % of merchandise exports) of Cyprus in 2009?
Provide a short and direct response. 13.19. What is the difference between the Imports(as % of merchandise exports) in North America in 2008 and the Imports(as % of merchandise exports) in Albania in 2009?
Your answer should be compact. 9.73. What is the difference between the Imports(as % of merchandise exports) in North America in 2008 and the Imports(as % of merchandise exports) in Cyprus in 2009?
Provide a short and direct response. 3.96. What is the difference between the Imports(as % of merchandise exports) in Albania in 2008 and the Imports(as % of merchandise exports) in Cyprus in 2009?
Provide a short and direct response. -1.55. What is the difference between the Imports(as % of merchandise exports) of Caribbean small states in 2008 and the Imports(as % of merchandise exports) of North America in 2010?
Keep it short and to the point. 13.51. What is the difference between the Imports(as % of merchandise exports) in Caribbean small states in 2008 and the Imports(as % of merchandise exports) in Albania in 2010?
Offer a very short reply. 16.95. What is the difference between the Imports(as % of merchandise exports) in Caribbean small states in 2008 and the Imports(as % of merchandise exports) in Cyprus in 2010?
Ensure brevity in your answer.  10.61. What is the difference between the Imports(as % of merchandise exports) of North America in 2008 and the Imports(as % of merchandise exports) of Albania in 2010?
Ensure brevity in your answer.  7.71. What is the difference between the Imports(as % of merchandise exports) of North America in 2008 and the Imports(as % of merchandise exports) of Cyprus in 2010?
Provide a succinct answer. 1.37. What is the difference between the Imports(as % of merchandise exports) of Albania in 2008 and the Imports(as % of merchandise exports) of Cyprus in 2010?
Make the answer very short. -4.14. What is the difference between the Imports(as % of merchandise exports) of Caribbean small states in 2009 and the Imports(as % of merchandise exports) of North America in 2010?
Give a very brief answer. 7.26. What is the difference between the Imports(as % of merchandise exports) of Caribbean small states in 2009 and the Imports(as % of merchandise exports) of Albania in 2010?
Ensure brevity in your answer.  10.7. What is the difference between the Imports(as % of merchandise exports) of Caribbean small states in 2009 and the Imports(as % of merchandise exports) of Cyprus in 2010?
Provide a short and direct response. 4.36. What is the difference between the Imports(as % of merchandise exports) in North America in 2009 and the Imports(as % of merchandise exports) in Albania in 2010?
Provide a short and direct response. 2.44. What is the difference between the Imports(as % of merchandise exports) in North America in 2009 and the Imports(as % of merchandise exports) in Cyprus in 2010?
Offer a terse response. -3.9. What is the difference between the Imports(as % of merchandise exports) in Albania in 2009 and the Imports(as % of merchandise exports) in Cyprus in 2010?
Your answer should be compact. -8.36. What is the average Imports(as % of merchandise exports) in Caribbean small states per year?
Your response must be concise. 24.66. What is the average Imports(as % of merchandise exports) of North America per year?
Offer a very short reply. 16.16. What is the average Imports(as % of merchandise exports) of Albania per year?
Ensure brevity in your answer.  11.72. What is the average Imports(as % of merchandise exports) in Cyprus per year?
Provide a short and direct response. 16.3. In the year 2003, what is the difference between the Imports(as % of merchandise exports) in Caribbean small states and Imports(as % of merchandise exports) in North America?
Your answer should be very brief. 8.48. In the year 2003, what is the difference between the Imports(as % of merchandise exports) in Caribbean small states and Imports(as % of merchandise exports) in Albania?
Make the answer very short. 11.46. In the year 2003, what is the difference between the Imports(as % of merchandise exports) of Caribbean small states and Imports(as % of merchandise exports) of Cyprus?
Your response must be concise. 10.1. In the year 2003, what is the difference between the Imports(as % of merchandise exports) in North America and Imports(as % of merchandise exports) in Albania?
Keep it short and to the point. 2.98. In the year 2003, what is the difference between the Imports(as % of merchandise exports) in North America and Imports(as % of merchandise exports) in Cyprus?
Your response must be concise. 1.62. In the year 2003, what is the difference between the Imports(as % of merchandise exports) of Albania and Imports(as % of merchandise exports) of Cyprus?
Give a very brief answer. -1.37. In the year 2004, what is the difference between the Imports(as % of merchandise exports) in Caribbean small states and Imports(as % of merchandise exports) in North America?
Give a very brief answer. 6.17. In the year 2004, what is the difference between the Imports(as % of merchandise exports) in Caribbean small states and Imports(as % of merchandise exports) in Albania?
Your response must be concise. 11.54. In the year 2004, what is the difference between the Imports(as % of merchandise exports) in Caribbean small states and Imports(as % of merchandise exports) in Cyprus?
Offer a very short reply. 7.24. In the year 2004, what is the difference between the Imports(as % of merchandise exports) of North America and Imports(as % of merchandise exports) of Albania?
Your response must be concise. 5.37. In the year 2004, what is the difference between the Imports(as % of merchandise exports) of North America and Imports(as % of merchandise exports) of Cyprus?
Offer a terse response. 1.07. In the year 2004, what is the difference between the Imports(as % of merchandise exports) in Albania and Imports(as % of merchandise exports) in Cyprus?
Make the answer very short. -4.3. In the year 2005, what is the difference between the Imports(as % of merchandise exports) of Caribbean small states and Imports(as % of merchandise exports) of North America?
Offer a terse response. 10.45. In the year 2005, what is the difference between the Imports(as % of merchandise exports) of Caribbean small states and Imports(as % of merchandise exports) of Albania?
Provide a succinct answer. 17.45. In the year 2005, what is the difference between the Imports(as % of merchandise exports) of Caribbean small states and Imports(as % of merchandise exports) of Cyprus?
Keep it short and to the point. 10.27. In the year 2005, what is the difference between the Imports(as % of merchandise exports) of North America and Imports(as % of merchandise exports) of Albania?
Your answer should be compact. 7. In the year 2005, what is the difference between the Imports(as % of merchandise exports) in North America and Imports(as % of merchandise exports) in Cyprus?
Provide a succinct answer. -0.18. In the year 2005, what is the difference between the Imports(as % of merchandise exports) in Albania and Imports(as % of merchandise exports) in Cyprus?
Offer a terse response. -7.18. In the year 2006, what is the difference between the Imports(as % of merchandise exports) in Caribbean small states and Imports(as % of merchandise exports) in North America?
Ensure brevity in your answer.  9.06. In the year 2006, what is the difference between the Imports(as % of merchandise exports) of Caribbean small states and Imports(as % of merchandise exports) of Albania?
Offer a terse response. 13.44. In the year 2006, what is the difference between the Imports(as % of merchandise exports) of Caribbean small states and Imports(as % of merchandise exports) of Cyprus?
Offer a terse response. 7.59. In the year 2006, what is the difference between the Imports(as % of merchandise exports) in North America and Imports(as % of merchandise exports) in Albania?
Ensure brevity in your answer.  4.38. In the year 2006, what is the difference between the Imports(as % of merchandise exports) of North America and Imports(as % of merchandise exports) of Cyprus?
Offer a terse response. -1.47. In the year 2006, what is the difference between the Imports(as % of merchandise exports) of Albania and Imports(as % of merchandise exports) of Cyprus?
Offer a very short reply. -5.85. In the year 2007, what is the difference between the Imports(as % of merchandise exports) of Caribbean small states and Imports(as % of merchandise exports) of North America?
Your answer should be compact. 8.2. In the year 2007, what is the difference between the Imports(as % of merchandise exports) in Caribbean small states and Imports(as % of merchandise exports) in Albania?
Offer a very short reply. 10.56. In the year 2007, what is the difference between the Imports(as % of merchandise exports) in Caribbean small states and Imports(as % of merchandise exports) in Cyprus?
Provide a succinct answer. 8.4. In the year 2007, what is the difference between the Imports(as % of merchandise exports) of North America and Imports(as % of merchandise exports) of Albania?
Offer a very short reply. 2.36. In the year 2007, what is the difference between the Imports(as % of merchandise exports) of North America and Imports(as % of merchandise exports) of Cyprus?
Your answer should be compact. 0.2. In the year 2007, what is the difference between the Imports(as % of merchandise exports) of Albania and Imports(as % of merchandise exports) of Cyprus?
Your response must be concise. -2.16. In the year 2008, what is the difference between the Imports(as % of merchandise exports) in Caribbean small states and Imports(as % of merchandise exports) in North America?
Keep it short and to the point. 9.23. In the year 2008, what is the difference between the Imports(as % of merchandise exports) of Caribbean small states and Imports(as % of merchandise exports) of Albania?
Provide a succinct answer. 14.74. In the year 2008, what is the difference between the Imports(as % of merchandise exports) in Caribbean small states and Imports(as % of merchandise exports) in Cyprus?
Your answer should be very brief. 11.08. In the year 2008, what is the difference between the Imports(as % of merchandise exports) of North America and Imports(as % of merchandise exports) of Albania?
Your answer should be very brief. 5.51. In the year 2008, what is the difference between the Imports(as % of merchandise exports) in North America and Imports(as % of merchandise exports) in Cyprus?
Provide a short and direct response. 1.85. In the year 2008, what is the difference between the Imports(as % of merchandise exports) of Albania and Imports(as % of merchandise exports) of Cyprus?
Offer a very short reply. -3.66. In the year 2009, what is the difference between the Imports(as % of merchandise exports) in Caribbean small states and Imports(as % of merchandise exports) in North America?
Offer a very short reply. 8.26. In the year 2009, what is the difference between the Imports(as % of merchandise exports) of Caribbean small states and Imports(as % of merchandise exports) of Albania?
Keep it short and to the point. 12.72. In the year 2009, what is the difference between the Imports(as % of merchandise exports) of Caribbean small states and Imports(as % of merchandise exports) of Cyprus?
Make the answer very short. 6.94. In the year 2009, what is the difference between the Imports(as % of merchandise exports) in North America and Imports(as % of merchandise exports) in Albania?
Give a very brief answer. 4.46. In the year 2009, what is the difference between the Imports(as % of merchandise exports) in North America and Imports(as % of merchandise exports) in Cyprus?
Your response must be concise. -1.32. In the year 2009, what is the difference between the Imports(as % of merchandise exports) of Albania and Imports(as % of merchandise exports) of Cyprus?
Ensure brevity in your answer.  -5.77. In the year 2010, what is the difference between the Imports(as % of merchandise exports) of Caribbean small states and Imports(as % of merchandise exports) of North America?
Keep it short and to the point. 8.13. In the year 2010, what is the difference between the Imports(as % of merchandise exports) in Caribbean small states and Imports(as % of merchandise exports) in Albania?
Offer a terse response. 11.56. In the year 2010, what is the difference between the Imports(as % of merchandise exports) of Caribbean small states and Imports(as % of merchandise exports) of Cyprus?
Make the answer very short. 5.22. In the year 2010, what is the difference between the Imports(as % of merchandise exports) of North America and Imports(as % of merchandise exports) of Albania?
Offer a terse response. 3.43. In the year 2010, what is the difference between the Imports(as % of merchandise exports) of North America and Imports(as % of merchandise exports) of Cyprus?
Your answer should be compact. -2.9. In the year 2010, what is the difference between the Imports(as % of merchandise exports) in Albania and Imports(as % of merchandise exports) in Cyprus?
Offer a terse response. -6.34. What is the ratio of the Imports(as % of merchandise exports) in Caribbean small states in 2003 to that in 2004?
Keep it short and to the point. 1.04. What is the ratio of the Imports(as % of merchandise exports) of North America in 2003 to that in 2004?
Provide a short and direct response. 0.88. What is the ratio of the Imports(as % of merchandise exports) in Albania in 2003 to that in 2004?
Ensure brevity in your answer.  1.11. What is the ratio of the Imports(as % of merchandise exports) in Cyprus in 2003 to that in 2004?
Your response must be concise. 0.83. What is the ratio of the Imports(as % of merchandise exports) of Caribbean small states in 2003 to that in 2005?
Make the answer very short. 0.76. What is the ratio of the Imports(as % of merchandise exports) of North America in 2003 to that in 2005?
Your answer should be compact. 0.72. What is the ratio of the Imports(as % of merchandise exports) in Albania in 2003 to that in 2005?
Give a very brief answer. 0.96. What is the ratio of the Imports(as % of merchandise exports) in Cyprus in 2003 to that in 2005?
Provide a short and direct response. 0.62. What is the ratio of the Imports(as % of merchandise exports) in Caribbean small states in 2003 to that in 2006?
Give a very brief answer. 0.78. What is the ratio of the Imports(as % of merchandise exports) in North America in 2003 to that in 2006?
Provide a succinct answer. 0.7. What is the ratio of the Imports(as % of merchandise exports) in Albania in 2003 to that in 2006?
Provide a succinct answer. 0.7. What is the ratio of the Imports(as % of merchandise exports) of Cyprus in 2003 to that in 2006?
Make the answer very short. 0.55. What is the ratio of the Imports(as % of merchandise exports) in Caribbean small states in 2003 to that in 2007?
Offer a terse response. 0.79. What is the ratio of the Imports(as % of merchandise exports) of North America in 2003 to that in 2007?
Your response must be concise. 0.68. What is the ratio of the Imports(as % of merchandise exports) of Albania in 2003 to that in 2007?
Keep it short and to the point. 0.58. What is the ratio of the Imports(as % of merchandise exports) in Cyprus in 2003 to that in 2007?
Provide a short and direct response. 0.59. What is the ratio of the Imports(as % of merchandise exports) of Caribbean small states in 2003 to that in 2008?
Make the answer very short. 0.65. What is the ratio of the Imports(as % of merchandise exports) of North America in 2003 to that in 2008?
Your answer should be compact. 0.54. What is the ratio of the Imports(as % of merchandise exports) of Albania in 2003 to that in 2008?
Make the answer very short. 0.53. What is the ratio of the Imports(as % of merchandise exports) of Cyprus in 2003 to that in 2008?
Ensure brevity in your answer.  0.5. What is the ratio of the Imports(as % of merchandise exports) in Caribbean small states in 2003 to that in 2009?
Give a very brief answer. 0.82. What is the ratio of the Imports(as % of merchandise exports) of North America in 2003 to that in 2009?
Keep it short and to the point. 0.71. What is the ratio of the Imports(as % of merchandise exports) of Albania in 2003 to that in 2009?
Provide a short and direct response. 0.73. What is the ratio of the Imports(as % of merchandise exports) of Cyprus in 2003 to that in 2009?
Your answer should be compact. 0.57. What is the ratio of the Imports(as % of merchandise exports) in Caribbean small states in 2003 to that in 2010?
Make the answer very short. 0.79. What is the ratio of the Imports(as % of merchandise exports) in North America in 2003 to that in 2010?
Offer a terse response. 0.67. What is the ratio of the Imports(as % of merchandise exports) in Albania in 2003 to that in 2010?
Offer a very short reply. 0.62. What is the ratio of the Imports(as % of merchandise exports) in Cyprus in 2003 to that in 2010?
Provide a short and direct response. 0.49. What is the ratio of the Imports(as % of merchandise exports) in Caribbean small states in 2004 to that in 2005?
Offer a very short reply. 0.73. What is the ratio of the Imports(as % of merchandise exports) in North America in 2004 to that in 2005?
Give a very brief answer. 0.82. What is the ratio of the Imports(as % of merchandise exports) in Albania in 2004 to that in 2005?
Ensure brevity in your answer.  0.86. What is the ratio of the Imports(as % of merchandise exports) in Cyprus in 2004 to that in 2005?
Your answer should be compact. 0.74. What is the ratio of the Imports(as % of merchandise exports) in Caribbean small states in 2004 to that in 2006?
Ensure brevity in your answer.  0.75. What is the ratio of the Imports(as % of merchandise exports) in North America in 2004 to that in 2006?
Your answer should be very brief. 0.79. What is the ratio of the Imports(as % of merchandise exports) in Albania in 2004 to that in 2006?
Offer a very short reply. 0.63. What is the ratio of the Imports(as % of merchandise exports) in Cyprus in 2004 to that in 2006?
Keep it short and to the point. 0.66. What is the ratio of the Imports(as % of merchandise exports) in Caribbean small states in 2004 to that in 2007?
Your response must be concise. 0.76. What is the ratio of the Imports(as % of merchandise exports) of North America in 2004 to that in 2007?
Your answer should be very brief. 0.77. What is the ratio of the Imports(as % of merchandise exports) of Albania in 2004 to that in 2007?
Offer a very short reply. 0.53. What is the ratio of the Imports(as % of merchandise exports) of Cyprus in 2004 to that in 2007?
Provide a succinct answer. 0.71. What is the ratio of the Imports(as % of merchandise exports) of Caribbean small states in 2004 to that in 2008?
Offer a terse response. 0.63. What is the ratio of the Imports(as % of merchandise exports) in North America in 2004 to that in 2008?
Your response must be concise. 0.61. What is the ratio of the Imports(as % of merchandise exports) of Albania in 2004 to that in 2008?
Make the answer very short. 0.48. What is the ratio of the Imports(as % of merchandise exports) of Cyprus in 2004 to that in 2008?
Keep it short and to the point. 0.61. What is the ratio of the Imports(as % of merchandise exports) of Caribbean small states in 2004 to that in 2009?
Offer a very short reply. 0.79. What is the ratio of the Imports(as % of merchandise exports) of North America in 2004 to that in 2009?
Your answer should be compact. 0.81. What is the ratio of the Imports(as % of merchandise exports) in Albania in 2004 to that in 2009?
Provide a short and direct response. 0.65. What is the ratio of the Imports(as % of merchandise exports) in Cyprus in 2004 to that in 2009?
Offer a terse response. 0.68. What is the ratio of the Imports(as % of merchandise exports) of Caribbean small states in 2004 to that in 2010?
Your answer should be very brief. 0.76. What is the ratio of the Imports(as % of merchandise exports) of North America in 2004 to that in 2010?
Give a very brief answer. 0.76. What is the ratio of the Imports(as % of merchandise exports) in Albania in 2004 to that in 2010?
Keep it short and to the point. 0.56. What is the ratio of the Imports(as % of merchandise exports) in Cyprus in 2004 to that in 2010?
Provide a short and direct response. 0.6. What is the ratio of the Imports(as % of merchandise exports) of Caribbean small states in 2005 to that in 2006?
Your answer should be compact. 1.03. What is the ratio of the Imports(as % of merchandise exports) in Albania in 2005 to that in 2006?
Your response must be concise. 0.73. What is the ratio of the Imports(as % of merchandise exports) of Cyprus in 2005 to that in 2006?
Give a very brief answer. 0.89. What is the ratio of the Imports(as % of merchandise exports) of Caribbean small states in 2005 to that in 2007?
Make the answer very short. 1.05. What is the ratio of the Imports(as % of merchandise exports) in North America in 2005 to that in 2007?
Provide a short and direct response. 0.94. What is the ratio of the Imports(as % of merchandise exports) of Albania in 2005 to that in 2007?
Offer a terse response. 0.61. What is the ratio of the Imports(as % of merchandise exports) in Cyprus in 2005 to that in 2007?
Ensure brevity in your answer.  0.96. What is the ratio of the Imports(as % of merchandise exports) in Caribbean small states in 2005 to that in 2008?
Provide a short and direct response. 0.86. What is the ratio of the Imports(as % of merchandise exports) in North America in 2005 to that in 2008?
Your answer should be compact. 0.74. What is the ratio of the Imports(as % of merchandise exports) in Albania in 2005 to that in 2008?
Your answer should be very brief. 0.56. What is the ratio of the Imports(as % of merchandise exports) in Cyprus in 2005 to that in 2008?
Offer a very short reply. 0.82. What is the ratio of the Imports(as % of merchandise exports) of Caribbean small states in 2005 to that in 2009?
Give a very brief answer. 1.08. What is the ratio of the Imports(as % of merchandise exports) of North America in 2005 to that in 2009?
Your response must be concise. 0.98. What is the ratio of the Imports(as % of merchandise exports) of Albania in 2005 to that in 2009?
Offer a very short reply. 0.76. What is the ratio of the Imports(as % of merchandise exports) of Cyprus in 2005 to that in 2009?
Your response must be concise. 0.92. What is the ratio of the Imports(as % of merchandise exports) in Caribbean small states in 2005 to that in 2010?
Give a very brief answer. 1.04. What is the ratio of the Imports(as % of merchandise exports) of North America in 2005 to that in 2010?
Your answer should be very brief. 0.93. What is the ratio of the Imports(as % of merchandise exports) in Albania in 2005 to that in 2010?
Give a very brief answer. 0.65. What is the ratio of the Imports(as % of merchandise exports) of Cyprus in 2005 to that in 2010?
Give a very brief answer. 0.8. What is the ratio of the Imports(as % of merchandise exports) in Caribbean small states in 2006 to that in 2007?
Make the answer very short. 1.02. What is the ratio of the Imports(as % of merchandise exports) in North America in 2006 to that in 2007?
Give a very brief answer. 0.98. What is the ratio of the Imports(as % of merchandise exports) of Albania in 2006 to that in 2007?
Your answer should be compact. 0.83. What is the ratio of the Imports(as % of merchandise exports) in Cyprus in 2006 to that in 2007?
Offer a very short reply. 1.08. What is the ratio of the Imports(as % of merchandise exports) in Caribbean small states in 2006 to that in 2008?
Give a very brief answer. 0.83. What is the ratio of the Imports(as % of merchandise exports) of North America in 2006 to that in 2008?
Provide a short and direct response. 0.77. What is the ratio of the Imports(as % of merchandise exports) in Albania in 2006 to that in 2008?
Your answer should be very brief. 0.76. What is the ratio of the Imports(as % of merchandise exports) of Cyprus in 2006 to that in 2008?
Ensure brevity in your answer.  0.92. What is the ratio of the Imports(as % of merchandise exports) in Caribbean small states in 2006 to that in 2009?
Provide a short and direct response. 1.05. What is the ratio of the Imports(as % of merchandise exports) in North America in 2006 to that in 2009?
Provide a short and direct response. 1.02. What is the ratio of the Imports(as % of merchandise exports) in Albania in 2006 to that in 2009?
Your answer should be compact. 1.04. What is the ratio of the Imports(as % of merchandise exports) of Cyprus in 2006 to that in 2009?
Provide a succinct answer. 1.03. What is the ratio of the Imports(as % of merchandise exports) of Caribbean small states in 2006 to that in 2010?
Offer a very short reply. 1.01. What is the ratio of the Imports(as % of merchandise exports) of North America in 2006 to that in 2010?
Your answer should be compact. 0.96. What is the ratio of the Imports(as % of merchandise exports) of Albania in 2006 to that in 2010?
Your response must be concise. 0.89. What is the ratio of the Imports(as % of merchandise exports) of Cyprus in 2006 to that in 2010?
Keep it short and to the point. 0.9. What is the ratio of the Imports(as % of merchandise exports) of Caribbean small states in 2007 to that in 2008?
Make the answer very short. 0.82. What is the ratio of the Imports(as % of merchandise exports) in North America in 2007 to that in 2008?
Provide a succinct answer. 0.79. What is the ratio of the Imports(as % of merchandise exports) in Albania in 2007 to that in 2008?
Ensure brevity in your answer.  0.91. What is the ratio of the Imports(as % of merchandise exports) of Cyprus in 2007 to that in 2008?
Provide a succinct answer. 0.85. What is the ratio of the Imports(as % of merchandise exports) in Caribbean small states in 2007 to that in 2009?
Provide a succinct answer. 1.03. What is the ratio of the Imports(as % of merchandise exports) in North America in 2007 to that in 2009?
Ensure brevity in your answer.  1.05. What is the ratio of the Imports(as % of merchandise exports) of Albania in 2007 to that in 2009?
Give a very brief answer. 1.24. What is the ratio of the Imports(as % of merchandise exports) in Caribbean small states in 2007 to that in 2010?
Provide a succinct answer. 0.99. What is the ratio of the Imports(as % of merchandise exports) of North America in 2007 to that in 2010?
Give a very brief answer. 0.99. What is the ratio of the Imports(as % of merchandise exports) in Albania in 2007 to that in 2010?
Keep it short and to the point. 1.06. What is the ratio of the Imports(as % of merchandise exports) in Cyprus in 2007 to that in 2010?
Your response must be concise. 0.83. What is the ratio of the Imports(as % of merchandise exports) in Caribbean small states in 2008 to that in 2009?
Provide a succinct answer. 1.25. What is the ratio of the Imports(as % of merchandise exports) of North America in 2008 to that in 2009?
Offer a very short reply. 1.32. What is the ratio of the Imports(as % of merchandise exports) in Albania in 2008 to that in 2009?
Your answer should be very brief. 1.36. What is the ratio of the Imports(as % of merchandise exports) of Cyprus in 2008 to that in 2009?
Keep it short and to the point. 1.12. What is the ratio of the Imports(as % of merchandise exports) of Caribbean small states in 2008 to that in 2010?
Provide a succinct answer. 1.21. What is the ratio of the Imports(as % of merchandise exports) of North America in 2008 to that in 2010?
Your answer should be very brief. 1.25. What is the ratio of the Imports(as % of merchandise exports) in Albania in 2008 to that in 2010?
Keep it short and to the point. 1.16. What is the ratio of the Imports(as % of merchandise exports) of Cyprus in 2008 to that in 2010?
Your answer should be compact. 0.98. What is the ratio of the Imports(as % of merchandise exports) in Caribbean small states in 2009 to that in 2010?
Ensure brevity in your answer.  0.97. What is the ratio of the Imports(as % of merchandise exports) of North America in 2009 to that in 2010?
Offer a very short reply. 0.94. What is the ratio of the Imports(as % of merchandise exports) in Albania in 2009 to that in 2010?
Ensure brevity in your answer.  0.85. What is the ratio of the Imports(as % of merchandise exports) of Cyprus in 2009 to that in 2010?
Your answer should be compact. 0.87. What is the difference between the highest and the second highest Imports(as % of merchandise exports) of Caribbean small states?
Provide a succinct answer. 4.35. What is the difference between the highest and the second highest Imports(as % of merchandise exports) of North America?
Offer a terse response. 4.28. What is the difference between the highest and the second highest Imports(as % of merchandise exports) in Albania?
Provide a short and direct response. 1.37. What is the difference between the highest and the second highest Imports(as % of merchandise exports) of Cyprus?
Provide a succinct answer. 0.48. What is the difference between the highest and the lowest Imports(as % of merchandise exports) in Caribbean small states?
Keep it short and to the point. 11.51. What is the difference between the highest and the lowest Imports(as % of merchandise exports) in North America?
Give a very brief answer. 9.98. What is the difference between the highest and the lowest Imports(as % of merchandise exports) of Albania?
Make the answer very short. 8.31. What is the difference between the highest and the lowest Imports(as % of merchandise exports) of Cyprus?
Your answer should be very brief. 10.22. 